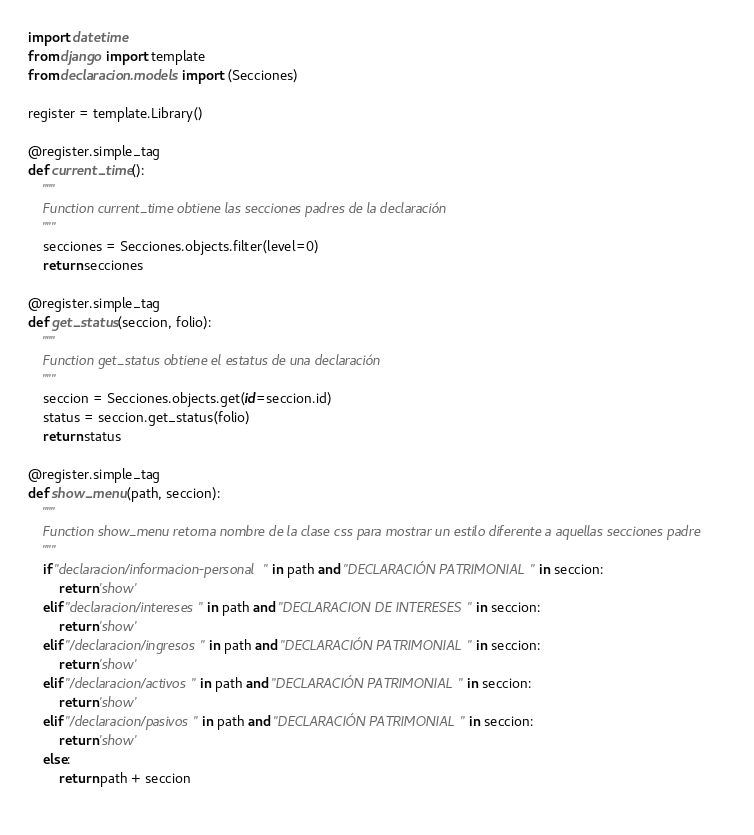<code> <loc_0><loc_0><loc_500><loc_500><_Python_>import datetime
from django import template
from declaracion.models import (Secciones)

register = template.Library()

@register.simple_tag
def current_time():
    """
    Function current_time obtiene las secciones padres de la declaración
    """
    secciones = Secciones.objects.filter(level=0)
    return secciones

@register.simple_tag
def get_status(seccion, folio):
    """
    Function get_status obtiene el estatus de una declaración
    """
    seccion = Secciones.objects.get(id=seccion.id)
    status = seccion.get_status(folio)
    return status

@register.simple_tag
def show_menu(path, seccion):
    """
    Function show_menu retorna nombre de la clase css para mostrar un estilo diferente a aquellas secciones padre
    """
    if "declaracion/informacion-personal" in path and "DECLARACIÓN PATRIMONIAL" in seccion:
        return 'show'
    elif "declaracion/intereses" in path and "DECLARACION DE INTERESES" in seccion:        
        return 'show'
    elif "/declaracion/ingresos" in path and "DECLARACIÓN PATRIMONIAL" in seccion:        
        return 'show'
    elif "/declaracion/activos" in path and "DECLARACIÓN PATRIMONIAL" in seccion:        
        return 'show'
    elif "/declaracion/pasivos" in path and "DECLARACIÓN PATRIMONIAL" in seccion:        
        return 'show'   
    else:
        return path + seccion
    
</code> 